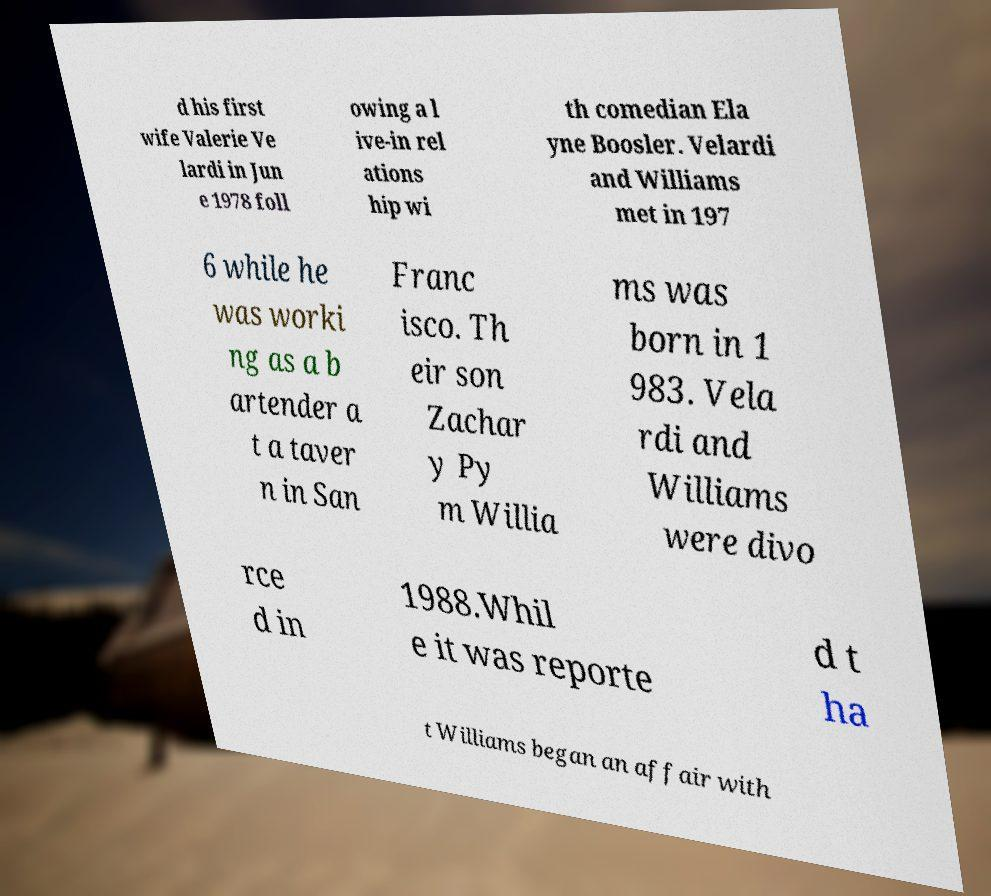Please identify and transcribe the text found in this image. d his first wife Valerie Ve lardi in Jun e 1978 foll owing a l ive-in rel ations hip wi th comedian Ela yne Boosler. Velardi and Williams met in 197 6 while he was worki ng as a b artender a t a taver n in San Franc isco. Th eir son Zachar y Py m Willia ms was born in 1 983. Vela rdi and Williams were divo rce d in 1988.Whil e it was reporte d t ha t Williams began an affair with 